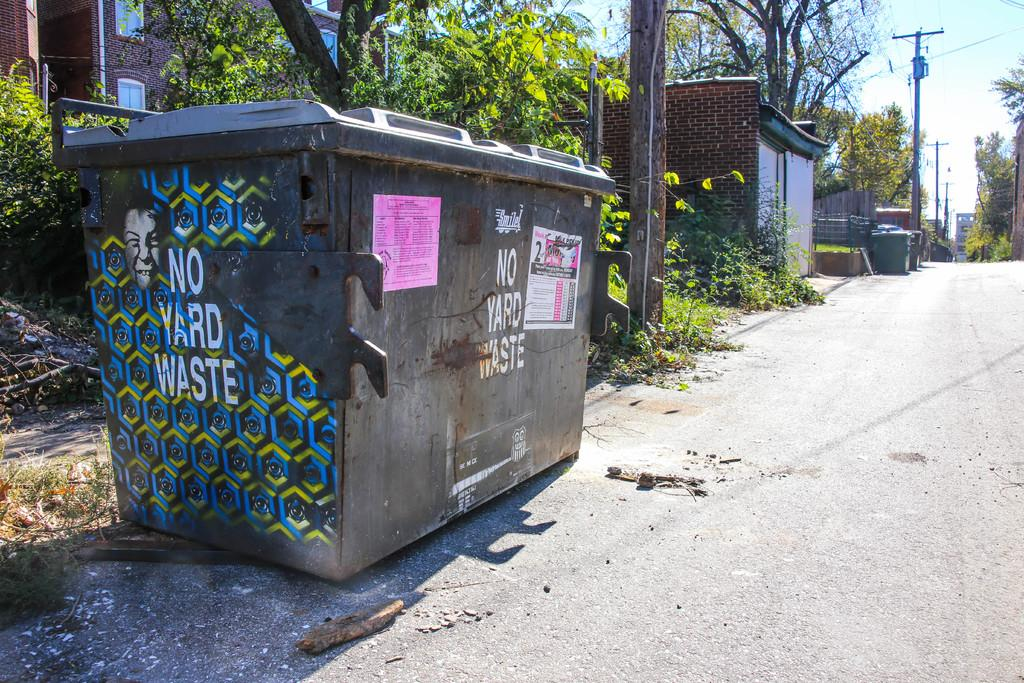Provide a one-sentence caption for the provided image. The dumpster sitting by the road says YARD WASTE. 